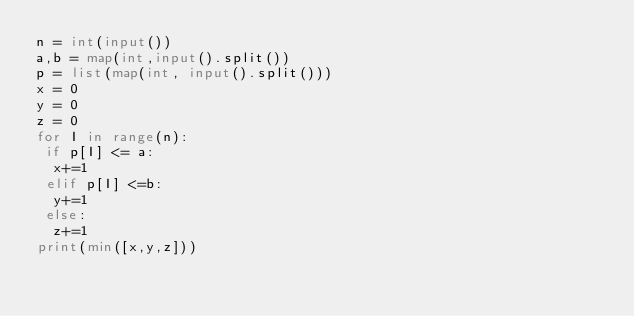<code> <loc_0><loc_0><loc_500><loc_500><_Python_>n = int(input())
a,b = map(int,input().split())
p = list(map(int, input().split()))
x = 0
y = 0
z = 0
for I in range(n):
 if p[I] <= a:
  x+=1
 elif p[I] <=b:
  y+=1
 else:
  z+=1
print(min([x,y,z]))</code> 